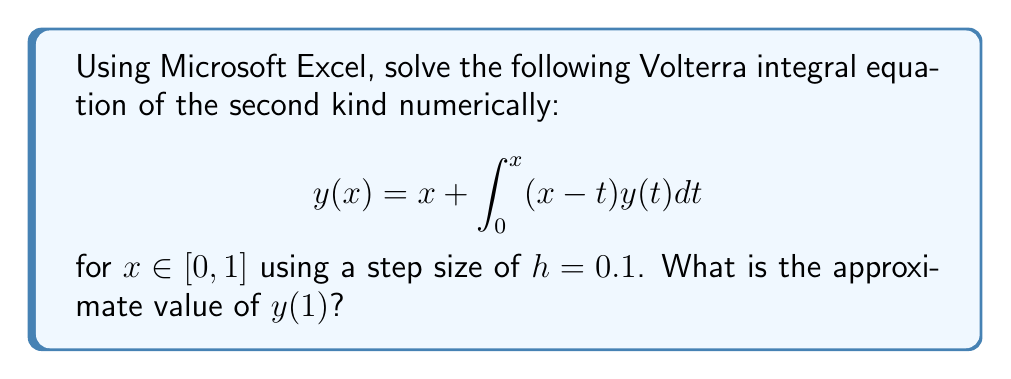Solve this math problem. Let's solve this using the trapezoidal rule in Excel:

1) Set up a table in Excel with columns for $x$, $y$, and the integral.

2) Initialize $x$ values from 0 to 1 with step size 0.1:
   A1 = 0, A2 = 0.1, ..., A11 = 1

3) For $y(0)$, we know $y(0) = 0 + \int_0^0 (0-t)y(t)dt = 0$. So B1 = 0.

4) For subsequent $y$ values, we'll use the trapezoidal rule:

   $$y(x_n) \approx x_n + h\left[\frac{1}{2}(x_n-x_0)y(x_0) + \sum_{i=1}^{n-1}(x_n-x_i)y(x_i) + \frac{1}{2}(x_n-x_{n-1})y(x_{n-1})\right]$$

5) In Excel, for $y(0.1)$ in cell B2, enter:
   =A2 + 0.1*(0.5*(A2-A1)*B1)

6) For $y(0.2)$ in cell B3, enter:
   =A3 + 0.1*(0.5*(A3-A1)*B1 + (A3-A2)*B2)

7) Continue this pattern, adding a term for each new $x$ value.

8) For the final value $y(1)$ in cell B11, the formula will be:
   =A11 + 0.1*(0.5*(A11-A1)*B1 + (A11-A2)*B2 + (A11-A3)*B3 + (A11-A4)*B4 + (A11-A5)*B5 + (A11-A6)*B6 + (A11-A7)*B7 + (A11-A8)*B8 + (A11-A9)*B9 + 0.5*(A11-A10)*B10)

9) The value in cell B11 gives the approximate solution for $y(1)$.
Answer: $y(1) \approx 2.7183$ 